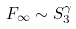Convert formula to latex. <formula><loc_0><loc_0><loc_500><loc_500>F _ { \infty } \sim S _ { 3 } ^ { \gamma }</formula> 